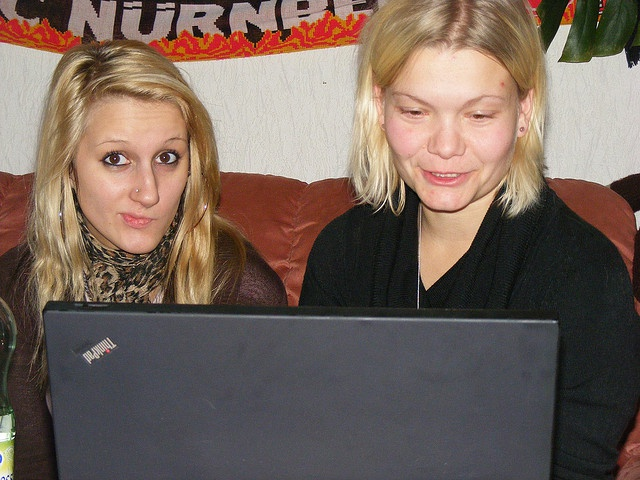Describe the objects in this image and their specific colors. I can see laptop in gray and black tones, people in gray, black, and tan tones, people in gray, black, and tan tones, and couch in gray, maroon, and brown tones in this image. 